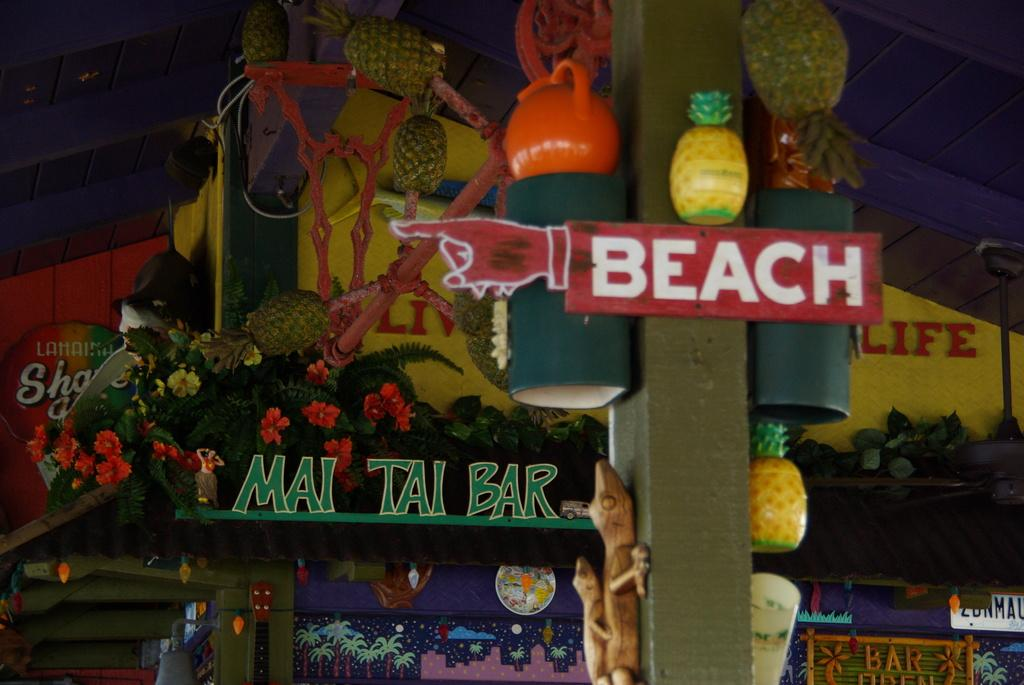<image>
Render a clear and concise summary of the photo. a pole that has the word beach on it 